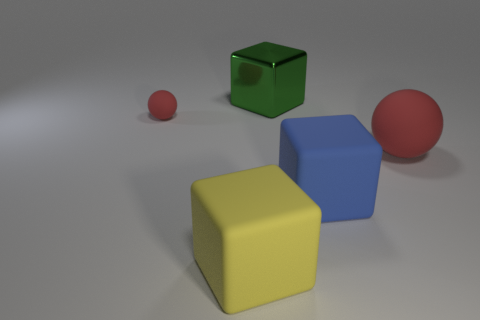Subtract all brown balls. Subtract all blue cubes. How many balls are left? 2 Add 1 big green metallic cubes. How many objects exist? 6 Subtract all balls. How many objects are left? 3 Add 1 big red things. How many big red things are left? 2 Add 2 big cyan metal objects. How many big cyan metal objects exist? 2 Subtract 0 brown spheres. How many objects are left? 5 Subtract all balls. Subtract all blue rubber objects. How many objects are left? 2 